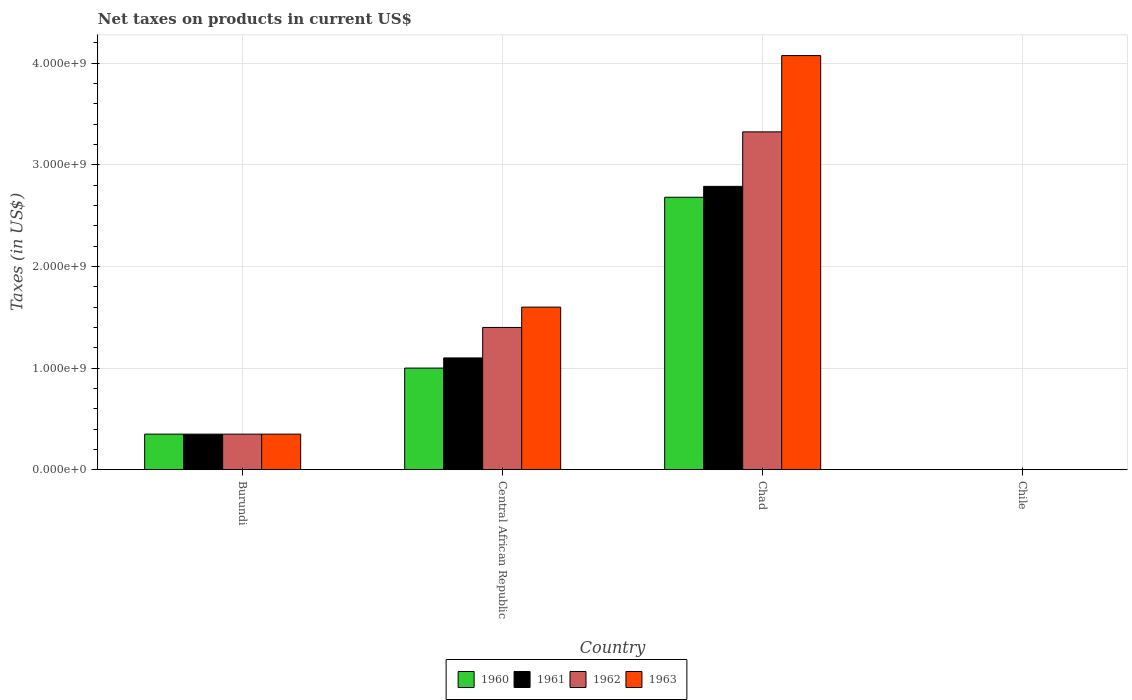How many different coloured bars are there?
Provide a short and direct response. 4. Are the number of bars per tick equal to the number of legend labels?
Give a very brief answer. Yes. Are the number of bars on each tick of the X-axis equal?
Your answer should be compact. Yes. How many bars are there on the 1st tick from the left?
Make the answer very short. 4. How many bars are there on the 3rd tick from the right?
Provide a succinct answer. 4. What is the label of the 4th group of bars from the left?
Keep it short and to the point. Chile. What is the net taxes on products in 1960 in Burundi?
Provide a succinct answer. 3.50e+08. Across all countries, what is the maximum net taxes on products in 1963?
Ensure brevity in your answer.  4.08e+09. Across all countries, what is the minimum net taxes on products in 1960?
Your answer should be compact. 2.02e+05. In which country was the net taxes on products in 1960 maximum?
Offer a very short reply. Chad. What is the total net taxes on products in 1963 in the graph?
Offer a terse response. 6.03e+09. What is the difference between the net taxes on products in 1963 in Central African Republic and that in Chile?
Ensure brevity in your answer.  1.60e+09. What is the difference between the net taxes on products in 1961 in Chile and the net taxes on products in 1963 in Chad?
Offer a terse response. -4.08e+09. What is the average net taxes on products in 1962 per country?
Offer a terse response. 1.27e+09. What is the difference between the net taxes on products of/in 1961 and net taxes on products of/in 1960 in Chad?
Offer a terse response. 1.07e+08. What is the ratio of the net taxes on products in 1963 in Central African Republic to that in Chile?
Ensure brevity in your answer.  4514.67. Is the net taxes on products in 1963 in Chad less than that in Chile?
Your answer should be compact. No. What is the difference between the highest and the second highest net taxes on products in 1961?
Ensure brevity in your answer.  -1.69e+09. What is the difference between the highest and the lowest net taxes on products in 1961?
Make the answer very short. 2.79e+09. In how many countries, is the net taxes on products in 1962 greater than the average net taxes on products in 1962 taken over all countries?
Your answer should be compact. 2. Are all the bars in the graph horizontal?
Keep it short and to the point. No. How many countries are there in the graph?
Make the answer very short. 4. What is the difference between two consecutive major ticks on the Y-axis?
Offer a terse response. 1.00e+09. Are the values on the major ticks of Y-axis written in scientific E-notation?
Ensure brevity in your answer.  Yes. Does the graph contain grids?
Your answer should be very brief. Yes. What is the title of the graph?
Your answer should be compact. Net taxes on products in current US$. Does "1999" appear as one of the legend labels in the graph?
Offer a terse response. No. What is the label or title of the X-axis?
Ensure brevity in your answer.  Country. What is the label or title of the Y-axis?
Provide a succinct answer. Taxes (in US$). What is the Taxes (in US$) in 1960 in Burundi?
Keep it short and to the point. 3.50e+08. What is the Taxes (in US$) of 1961 in Burundi?
Offer a very short reply. 3.50e+08. What is the Taxes (in US$) of 1962 in Burundi?
Your answer should be compact. 3.50e+08. What is the Taxes (in US$) of 1963 in Burundi?
Provide a short and direct response. 3.50e+08. What is the Taxes (in US$) of 1960 in Central African Republic?
Provide a short and direct response. 1.00e+09. What is the Taxes (in US$) in 1961 in Central African Republic?
Ensure brevity in your answer.  1.10e+09. What is the Taxes (in US$) in 1962 in Central African Republic?
Keep it short and to the point. 1.40e+09. What is the Taxes (in US$) in 1963 in Central African Republic?
Your response must be concise. 1.60e+09. What is the Taxes (in US$) in 1960 in Chad?
Offer a terse response. 2.68e+09. What is the Taxes (in US$) of 1961 in Chad?
Your answer should be very brief. 2.79e+09. What is the Taxes (in US$) in 1962 in Chad?
Offer a terse response. 3.32e+09. What is the Taxes (in US$) in 1963 in Chad?
Offer a terse response. 4.08e+09. What is the Taxes (in US$) of 1960 in Chile?
Give a very brief answer. 2.02e+05. What is the Taxes (in US$) in 1961 in Chile?
Make the answer very short. 2.53e+05. What is the Taxes (in US$) of 1962 in Chile?
Your answer should be very brief. 2.53e+05. What is the Taxes (in US$) of 1963 in Chile?
Your answer should be very brief. 3.54e+05. Across all countries, what is the maximum Taxes (in US$) in 1960?
Make the answer very short. 2.68e+09. Across all countries, what is the maximum Taxes (in US$) of 1961?
Your answer should be compact. 2.79e+09. Across all countries, what is the maximum Taxes (in US$) of 1962?
Ensure brevity in your answer.  3.32e+09. Across all countries, what is the maximum Taxes (in US$) in 1963?
Your answer should be very brief. 4.08e+09. Across all countries, what is the minimum Taxes (in US$) in 1960?
Give a very brief answer. 2.02e+05. Across all countries, what is the minimum Taxes (in US$) in 1961?
Your answer should be very brief. 2.53e+05. Across all countries, what is the minimum Taxes (in US$) of 1962?
Make the answer very short. 2.53e+05. Across all countries, what is the minimum Taxes (in US$) of 1963?
Offer a very short reply. 3.54e+05. What is the total Taxes (in US$) in 1960 in the graph?
Keep it short and to the point. 4.03e+09. What is the total Taxes (in US$) in 1961 in the graph?
Your answer should be compact. 4.24e+09. What is the total Taxes (in US$) of 1962 in the graph?
Offer a very short reply. 5.08e+09. What is the total Taxes (in US$) in 1963 in the graph?
Your answer should be compact. 6.03e+09. What is the difference between the Taxes (in US$) in 1960 in Burundi and that in Central African Republic?
Keep it short and to the point. -6.50e+08. What is the difference between the Taxes (in US$) of 1961 in Burundi and that in Central African Republic?
Your response must be concise. -7.50e+08. What is the difference between the Taxes (in US$) in 1962 in Burundi and that in Central African Republic?
Your answer should be compact. -1.05e+09. What is the difference between the Taxes (in US$) of 1963 in Burundi and that in Central African Republic?
Ensure brevity in your answer.  -1.25e+09. What is the difference between the Taxes (in US$) of 1960 in Burundi and that in Chad?
Provide a succinct answer. -2.33e+09. What is the difference between the Taxes (in US$) in 1961 in Burundi and that in Chad?
Make the answer very short. -2.44e+09. What is the difference between the Taxes (in US$) of 1962 in Burundi and that in Chad?
Give a very brief answer. -2.97e+09. What is the difference between the Taxes (in US$) in 1963 in Burundi and that in Chad?
Give a very brief answer. -3.73e+09. What is the difference between the Taxes (in US$) in 1960 in Burundi and that in Chile?
Offer a terse response. 3.50e+08. What is the difference between the Taxes (in US$) of 1961 in Burundi and that in Chile?
Offer a terse response. 3.50e+08. What is the difference between the Taxes (in US$) in 1962 in Burundi and that in Chile?
Your answer should be very brief. 3.50e+08. What is the difference between the Taxes (in US$) in 1963 in Burundi and that in Chile?
Provide a short and direct response. 3.50e+08. What is the difference between the Taxes (in US$) in 1960 in Central African Republic and that in Chad?
Your answer should be very brief. -1.68e+09. What is the difference between the Taxes (in US$) of 1961 in Central African Republic and that in Chad?
Provide a short and direct response. -1.69e+09. What is the difference between the Taxes (in US$) of 1962 in Central African Republic and that in Chad?
Offer a very short reply. -1.92e+09. What is the difference between the Taxes (in US$) of 1963 in Central African Republic and that in Chad?
Make the answer very short. -2.48e+09. What is the difference between the Taxes (in US$) in 1960 in Central African Republic and that in Chile?
Provide a short and direct response. 1.00e+09. What is the difference between the Taxes (in US$) in 1961 in Central African Republic and that in Chile?
Your answer should be compact. 1.10e+09. What is the difference between the Taxes (in US$) in 1962 in Central African Republic and that in Chile?
Offer a very short reply. 1.40e+09. What is the difference between the Taxes (in US$) in 1963 in Central African Republic and that in Chile?
Your response must be concise. 1.60e+09. What is the difference between the Taxes (in US$) in 1960 in Chad and that in Chile?
Offer a very short reply. 2.68e+09. What is the difference between the Taxes (in US$) of 1961 in Chad and that in Chile?
Offer a very short reply. 2.79e+09. What is the difference between the Taxes (in US$) of 1962 in Chad and that in Chile?
Your answer should be compact. 3.32e+09. What is the difference between the Taxes (in US$) of 1963 in Chad and that in Chile?
Your answer should be very brief. 4.08e+09. What is the difference between the Taxes (in US$) in 1960 in Burundi and the Taxes (in US$) in 1961 in Central African Republic?
Your answer should be very brief. -7.50e+08. What is the difference between the Taxes (in US$) in 1960 in Burundi and the Taxes (in US$) in 1962 in Central African Republic?
Offer a terse response. -1.05e+09. What is the difference between the Taxes (in US$) of 1960 in Burundi and the Taxes (in US$) of 1963 in Central African Republic?
Give a very brief answer. -1.25e+09. What is the difference between the Taxes (in US$) of 1961 in Burundi and the Taxes (in US$) of 1962 in Central African Republic?
Provide a short and direct response. -1.05e+09. What is the difference between the Taxes (in US$) of 1961 in Burundi and the Taxes (in US$) of 1963 in Central African Republic?
Provide a succinct answer. -1.25e+09. What is the difference between the Taxes (in US$) of 1962 in Burundi and the Taxes (in US$) of 1963 in Central African Republic?
Make the answer very short. -1.25e+09. What is the difference between the Taxes (in US$) in 1960 in Burundi and the Taxes (in US$) in 1961 in Chad?
Offer a very short reply. -2.44e+09. What is the difference between the Taxes (in US$) of 1960 in Burundi and the Taxes (in US$) of 1962 in Chad?
Make the answer very short. -2.97e+09. What is the difference between the Taxes (in US$) of 1960 in Burundi and the Taxes (in US$) of 1963 in Chad?
Your answer should be very brief. -3.73e+09. What is the difference between the Taxes (in US$) of 1961 in Burundi and the Taxes (in US$) of 1962 in Chad?
Your answer should be compact. -2.97e+09. What is the difference between the Taxes (in US$) in 1961 in Burundi and the Taxes (in US$) in 1963 in Chad?
Keep it short and to the point. -3.73e+09. What is the difference between the Taxes (in US$) of 1962 in Burundi and the Taxes (in US$) of 1963 in Chad?
Provide a succinct answer. -3.73e+09. What is the difference between the Taxes (in US$) of 1960 in Burundi and the Taxes (in US$) of 1961 in Chile?
Keep it short and to the point. 3.50e+08. What is the difference between the Taxes (in US$) in 1960 in Burundi and the Taxes (in US$) in 1962 in Chile?
Provide a succinct answer. 3.50e+08. What is the difference between the Taxes (in US$) of 1960 in Burundi and the Taxes (in US$) of 1963 in Chile?
Give a very brief answer. 3.50e+08. What is the difference between the Taxes (in US$) in 1961 in Burundi and the Taxes (in US$) in 1962 in Chile?
Make the answer very short. 3.50e+08. What is the difference between the Taxes (in US$) in 1961 in Burundi and the Taxes (in US$) in 1963 in Chile?
Offer a terse response. 3.50e+08. What is the difference between the Taxes (in US$) in 1962 in Burundi and the Taxes (in US$) in 1963 in Chile?
Offer a terse response. 3.50e+08. What is the difference between the Taxes (in US$) in 1960 in Central African Republic and the Taxes (in US$) in 1961 in Chad?
Your response must be concise. -1.79e+09. What is the difference between the Taxes (in US$) in 1960 in Central African Republic and the Taxes (in US$) in 1962 in Chad?
Give a very brief answer. -2.32e+09. What is the difference between the Taxes (in US$) of 1960 in Central African Republic and the Taxes (in US$) of 1963 in Chad?
Offer a terse response. -3.08e+09. What is the difference between the Taxes (in US$) of 1961 in Central African Republic and the Taxes (in US$) of 1962 in Chad?
Your answer should be very brief. -2.22e+09. What is the difference between the Taxes (in US$) of 1961 in Central African Republic and the Taxes (in US$) of 1963 in Chad?
Keep it short and to the point. -2.98e+09. What is the difference between the Taxes (in US$) of 1962 in Central African Republic and the Taxes (in US$) of 1963 in Chad?
Make the answer very short. -2.68e+09. What is the difference between the Taxes (in US$) of 1960 in Central African Republic and the Taxes (in US$) of 1961 in Chile?
Give a very brief answer. 1.00e+09. What is the difference between the Taxes (in US$) of 1960 in Central African Republic and the Taxes (in US$) of 1962 in Chile?
Provide a short and direct response. 1.00e+09. What is the difference between the Taxes (in US$) in 1960 in Central African Republic and the Taxes (in US$) in 1963 in Chile?
Your answer should be compact. 1.00e+09. What is the difference between the Taxes (in US$) in 1961 in Central African Republic and the Taxes (in US$) in 1962 in Chile?
Your answer should be compact. 1.10e+09. What is the difference between the Taxes (in US$) of 1961 in Central African Republic and the Taxes (in US$) of 1963 in Chile?
Offer a very short reply. 1.10e+09. What is the difference between the Taxes (in US$) in 1962 in Central African Republic and the Taxes (in US$) in 1963 in Chile?
Offer a very short reply. 1.40e+09. What is the difference between the Taxes (in US$) of 1960 in Chad and the Taxes (in US$) of 1961 in Chile?
Your answer should be compact. 2.68e+09. What is the difference between the Taxes (in US$) in 1960 in Chad and the Taxes (in US$) in 1962 in Chile?
Ensure brevity in your answer.  2.68e+09. What is the difference between the Taxes (in US$) in 1960 in Chad and the Taxes (in US$) in 1963 in Chile?
Your answer should be compact. 2.68e+09. What is the difference between the Taxes (in US$) in 1961 in Chad and the Taxes (in US$) in 1962 in Chile?
Provide a succinct answer. 2.79e+09. What is the difference between the Taxes (in US$) of 1961 in Chad and the Taxes (in US$) of 1963 in Chile?
Provide a succinct answer. 2.79e+09. What is the difference between the Taxes (in US$) in 1962 in Chad and the Taxes (in US$) in 1963 in Chile?
Provide a succinct answer. 3.32e+09. What is the average Taxes (in US$) of 1960 per country?
Provide a succinct answer. 1.01e+09. What is the average Taxes (in US$) in 1961 per country?
Offer a terse response. 1.06e+09. What is the average Taxes (in US$) of 1962 per country?
Your answer should be very brief. 1.27e+09. What is the average Taxes (in US$) of 1963 per country?
Offer a very short reply. 1.51e+09. What is the difference between the Taxes (in US$) in 1960 and Taxes (in US$) in 1963 in Burundi?
Your answer should be compact. 0. What is the difference between the Taxes (in US$) of 1961 and Taxes (in US$) of 1962 in Burundi?
Give a very brief answer. 0. What is the difference between the Taxes (in US$) of 1961 and Taxes (in US$) of 1963 in Burundi?
Provide a short and direct response. 0. What is the difference between the Taxes (in US$) in 1960 and Taxes (in US$) in 1961 in Central African Republic?
Ensure brevity in your answer.  -1.00e+08. What is the difference between the Taxes (in US$) of 1960 and Taxes (in US$) of 1962 in Central African Republic?
Make the answer very short. -4.00e+08. What is the difference between the Taxes (in US$) in 1960 and Taxes (in US$) in 1963 in Central African Republic?
Make the answer very short. -6.00e+08. What is the difference between the Taxes (in US$) of 1961 and Taxes (in US$) of 1962 in Central African Republic?
Ensure brevity in your answer.  -3.00e+08. What is the difference between the Taxes (in US$) in 1961 and Taxes (in US$) in 1963 in Central African Republic?
Offer a terse response. -5.00e+08. What is the difference between the Taxes (in US$) of 1962 and Taxes (in US$) of 1963 in Central African Republic?
Provide a succinct answer. -2.00e+08. What is the difference between the Taxes (in US$) of 1960 and Taxes (in US$) of 1961 in Chad?
Your answer should be very brief. -1.07e+08. What is the difference between the Taxes (in US$) in 1960 and Taxes (in US$) in 1962 in Chad?
Provide a short and direct response. -6.44e+08. What is the difference between the Taxes (in US$) of 1960 and Taxes (in US$) of 1963 in Chad?
Offer a terse response. -1.39e+09. What is the difference between the Taxes (in US$) in 1961 and Taxes (in US$) in 1962 in Chad?
Ensure brevity in your answer.  -5.36e+08. What is the difference between the Taxes (in US$) in 1961 and Taxes (in US$) in 1963 in Chad?
Provide a short and direct response. -1.29e+09. What is the difference between the Taxes (in US$) in 1962 and Taxes (in US$) in 1963 in Chad?
Offer a very short reply. -7.51e+08. What is the difference between the Taxes (in US$) in 1960 and Taxes (in US$) in 1961 in Chile?
Keep it short and to the point. -5.06e+04. What is the difference between the Taxes (in US$) of 1960 and Taxes (in US$) of 1962 in Chile?
Your answer should be very brief. -5.06e+04. What is the difference between the Taxes (in US$) of 1960 and Taxes (in US$) of 1963 in Chile?
Your answer should be very brief. -1.52e+05. What is the difference between the Taxes (in US$) in 1961 and Taxes (in US$) in 1962 in Chile?
Your answer should be very brief. 0. What is the difference between the Taxes (in US$) of 1961 and Taxes (in US$) of 1963 in Chile?
Your response must be concise. -1.01e+05. What is the difference between the Taxes (in US$) in 1962 and Taxes (in US$) in 1963 in Chile?
Keep it short and to the point. -1.01e+05. What is the ratio of the Taxes (in US$) of 1960 in Burundi to that in Central African Republic?
Offer a terse response. 0.35. What is the ratio of the Taxes (in US$) in 1961 in Burundi to that in Central African Republic?
Your answer should be compact. 0.32. What is the ratio of the Taxes (in US$) of 1963 in Burundi to that in Central African Republic?
Provide a short and direct response. 0.22. What is the ratio of the Taxes (in US$) in 1960 in Burundi to that in Chad?
Ensure brevity in your answer.  0.13. What is the ratio of the Taxes (in US$) in 1961 in Burundi to that in Chad?
Provide a short and direct response. 0.13. What is the ratio of the Taxes (in US$) in 1962 in Burundi to that in Chad?
Offer a very short reply. 0.11. What is the ratio of the Taxes (in US$) of 1963 in Burundi to that in Chad?
Your answer should be compact. 0.09. What is the ratio of the Taxes (in US$) in 1960 in Burundi to that in Chile?
Your answer should be compact. 1728.4. What is the ratio of the Taxes (in US$) of 1961 in Burundi to that in Chile?
Provide a short and direct response. 1382.85. What is the ratio of the Taxes (in US$) in 1962 in Burundi to that in Chile?
Your response must be concise. 1382.85. What is the ratio of the Taxes (in US$) of 1963 in Burundi to that in Chile?
Provide a succinct answer. 987.58. What is the ratio of the Taxes (in US$) in 1960 in Central African Republic to that in Chad?
Make the answer very short. 0.37. What is the ratio of the Taxes (in US$) of 1961 in Central African Republic to that in Chad?
Offer a very short reply. 0.39. What is the ratio of the Taxes (in US$) of 1962 in Central African Republic to that in Chad?
Your answer should be very brief. 0.42. What is the ratio of the Taxes (in US$) of 1963 in Central African Republic to that in Chad?
Offer a very short reply. 0.39. What is the ratio of the Taxes (in US$) in 1960 in Central African Republic to that in Chile?
Make the answer very short. 4938.27. What is the ratio of the Taxes (in US$) of 1961 in Central African Republic to that in Chile?
Provide a succinct answer. 4346.11. What is the ratio of the Taxes (in US$) in 1962 in Central African Republic to that in Chile?
Offer a terse response. 5531.41. What is the ratio of the Taxes (in US$) in 1963 in Central African Republic to that in Chile?
Offer a very short reply. 4514.67. What is the ratio of the Taxes (in US$) of 1960 in Chad to that in Chile?
Provide a short and direct response. 1.32e+04. What is the ratio of the Taxes (in US$) of 1961 in Chad to that in Chile?
Provide a succinct answer. 1.10e+04. What is the ratio of the Taxes (in US$) of 1962 in Chad to that in Chile?
Offer a very short reply. 1.31e+04. What is the ratio of the Taxes (in US$) in 1963 in Chad to that in Chile?
Give a very brief answer. 1.15e+04. What is the difference between the highest and the second highest Taxes (in US$) of 1960?
Ensure brevity in your answer.  1.68e+09. What is the difference between the highest and the second highest Taxes (in US$) of 1961?
Your answer should be very brief. 1.69e+09. What is the difference between the highest and the second highest Taxes (in US$) in 1962?
Offer a terse response. 1.92e+09. What is the difference between the highest and the second highest Taxes (in US$) of 1963?
Your response must be concise. 2.48e+09. What is the difference between the highest and the lowest Taxes (in US$) in 1960?
Offer a terse response. 2.68e+09. What is the difference between the highest and the lowest Taxes (in US$) of 1961?
Provide a succinct answer. 2.79e+09. What is the difference between the highest and the lowest Taxes (in US$) in 1962?
Provide a succinct answer. 3.32e+09. What is the difference between the highest and the lowest Taxes (in US$) in 1963?
Offer a terse response. 4.08e+09. 